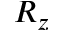<formula> <loc_0><loc_0><loc_500><loc_500>R _ { z }</formula> 